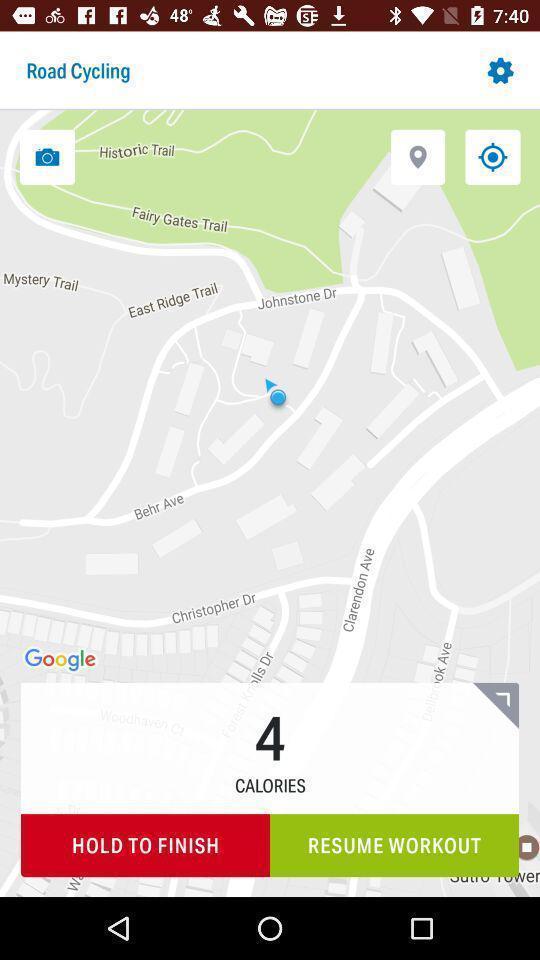Give me a narrative description of this picture. Page showing map with 4 calories in an workout application. 